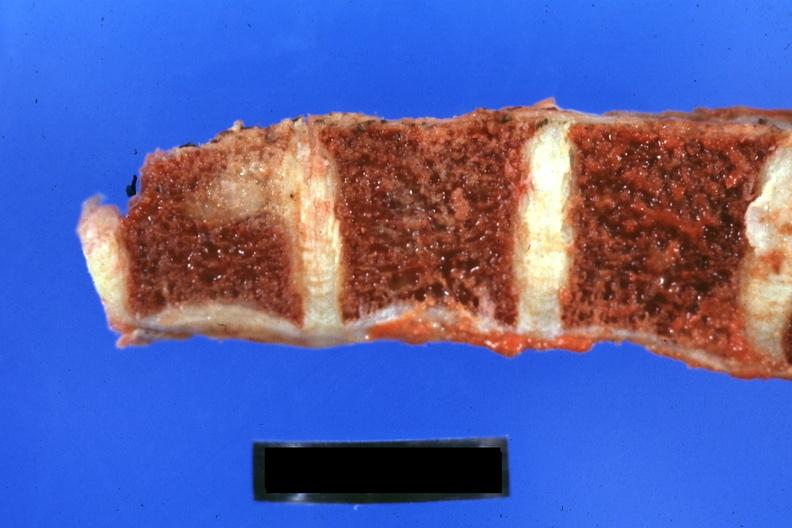when does this image show close-up of vertebra with obvious metastatic lesion 44yobfadenocarcinoma of lung giant cell type occurring 25 years?
Answer the question using a single word or phrase. After she was treat-ed for hodgkins disease 